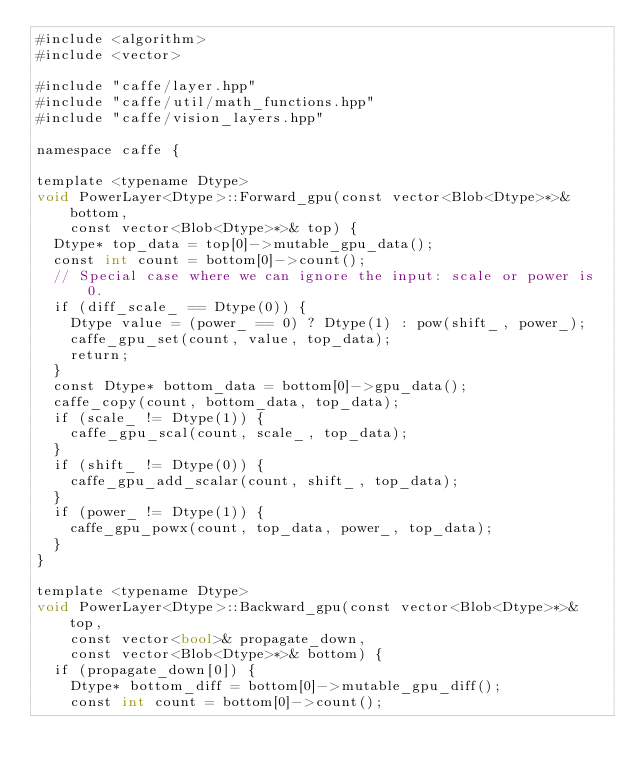Convert code to text. <code><loc_0><loc_0><loc_500><loc_500><_Cuda_>#include <algorithm>
#include <vector>

#include "caffe/layer.hpp"
#include "caffe/util/math_functions.hpp"
#include "caffe/vision_layers.hpp"

namespace caffe {

template <typename Dtype>
void PowerLayer<Dtype>::Forward_gpu(const vector<Blob<Dtype>*>& bottom,
    const vector<Blob<Dtype>*>& top) {
  Dtype* top_data = top[0]->mutable_gpu_data();
  const int count = bottom[0]->count();
  // Special case where we can ignore the input: scale or power is 0.
  if (diff_scale_ == Dtype(0)) {
    Dtype value = (power_ == 0) ? Dtype(1) : pow(shift_, power_);
    caffe_gpu_set(count, value, top_data);
    return;
  }
  const Dtype* bottom_data = bottom[0]->gpu_data();
  caffe_copy(count, bottom_data, top_data);
  if (scale_ != Dtype(1)) {
    caffe_gpu_scal(count, scale_, top_data);
  }
  if (shift_ != Dtype(0)) {
    caffe_gpu_add_scalar(count, shift_, top_data);
  }
  if (power_ != Dtype(1)) {
    caffe_gpu_powx(count, top_data, power_, top_data);
  }
}

template <typename Dtype>
void PowerLayer<Dtype>::Backward_gpu(const vector<Blob<Dtype>*>& top,
    const vector<bool>& propagate_down,
    const vector<Blob<Dtype>*>& bottom) {
  if (propagate_down[0]) {
    Dtype* bottom_diff = bottom[0]->mutable_gpu_diff();
    const int count = bottom[0]->count();</code> 